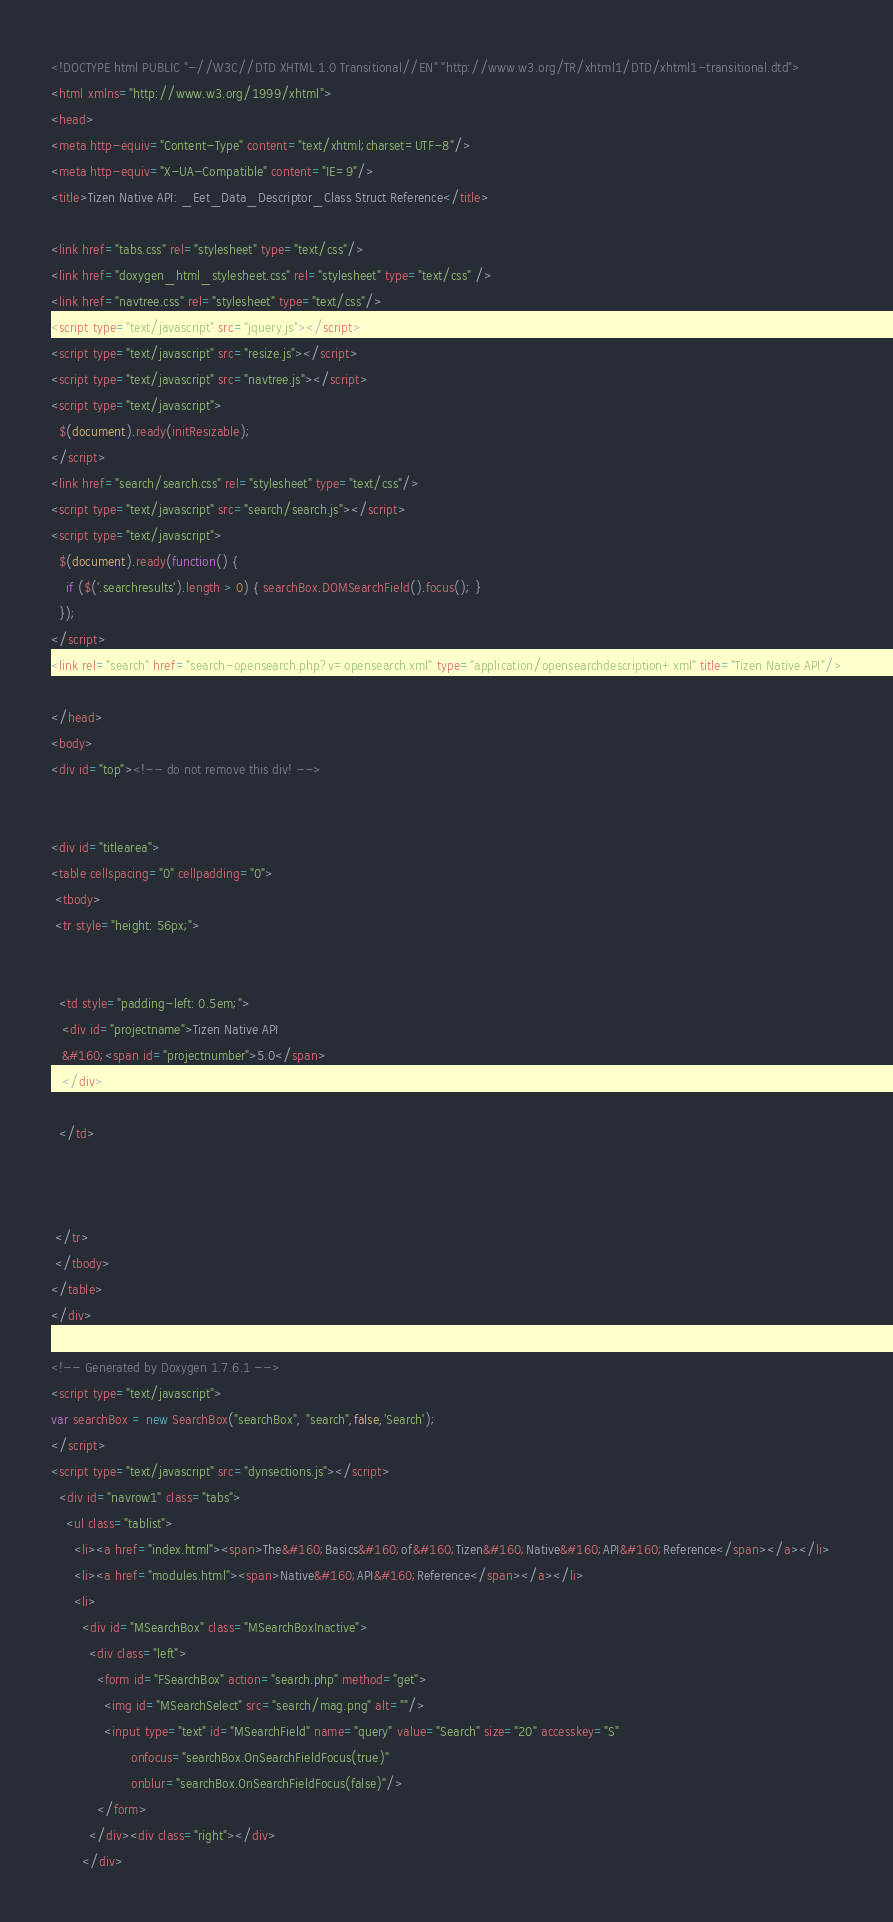Convert code to text. <code><loc_0><loc_0><loc_500><loc_500><_HTML_><!DOCTYPE html PUBLIC "-//W3C//DTD XHTML 1.0 Transitional//EN" "http://www.w3.org/TR/xhtml1/DTD/xhtml1-transitional.dtd">
<html xmlns="http://www.w3.org/1999/xhtml">
<head>
<meta http-equiv="Content-Type" content="text/xhtml;charset=UTF-8"/>
<meta http-equiv="X-UA-Compatible" content="IE=9"/>
<title>Tizen Native API: _Eet_Data_Descriptor_Class Struct Reference</title>

<link href="tabs.css" rel="stylesheet" type="text/css"/>
<link href="doxygen_html_stylesheet.css" rel="stylesheet" type="text/css" />
<link href="navtree.css" rel="stylesheet" type="text/css"/>
<script type="text/javascript" src="jquery.js"></script>
<script type="text/javascript" src="resize.js"></script>
<script type="text/javascript" src="navtree.js"></script>
<script type="text/javascript">
  $(document).ready(initResizable);
</script>
<link href="search/search.css" rel="stylesheet" type="text/css"/>
<script type="text/javascript" src="search/search.js"></script>
<script type="text/javascript">
  $(document).ready(function() {
    if ($('.searchresults').length > 0) { searchBox.DOMSearchField().focus(); }
  });
</script>
<link rel="search" href="search-opensearch.php?v=opensearch.xml" type="application/opensearchdescription+xml" title="Tizen Native API"/>

</head>
<body>
<div id="top"><!-- do not remove this div! -->


<div id="titlearea">
<table cellspacing="0" cellpadding="0">
 <tbody>
 <tr style="height: 56px;">
  
  
  <td style="padding-left: 0.5em;">
   <div id="projectname">Tizen Native API
   &#160;<span id="projectnumber">5.0</span>
   </div>
   
  </td>
  
  
  
 </tr>
 </tbody>
</table>
</div>

<!-- Generated by Doxygen 1.7.6.1 -->
<script type="text/javascript">
var searchBox = new SearchBox("searchBox", "search",false,'Search');
</script>
<script type="text/javascript" src="dynsections.js"></script>
  <div id="navrow1" class="tabs">
    <ul class="tablist">
      <li><a href="index.html"><span>The&#160;Basics&#160;of&#160;Tizen&#160;Native&#160;API&#160;Reference</span></a></li>
      <li><a href="modules.html"><span>Native&#160;API&#160;Reference</span></a></li>
      <li>
        <div id="MSearchBox" class="MSearchBoxInactive">
          <div class="left">
            <form id="FSearchBox" action="search.php" method="get">
              <img id="MSearchSelect" src="search/mag.png" alt=""/>
              <input type="text" id="MSearchField" name="query" value="Search" size="20" accesskey="S" 
                     onfocus="searchBox.OnSearchFieldFocus(true)" 
                     onblur="searchBox.OnSearchFieldFocus(false)"/>
            </form>
          </div><div class="right"></div>
        </div></code> 